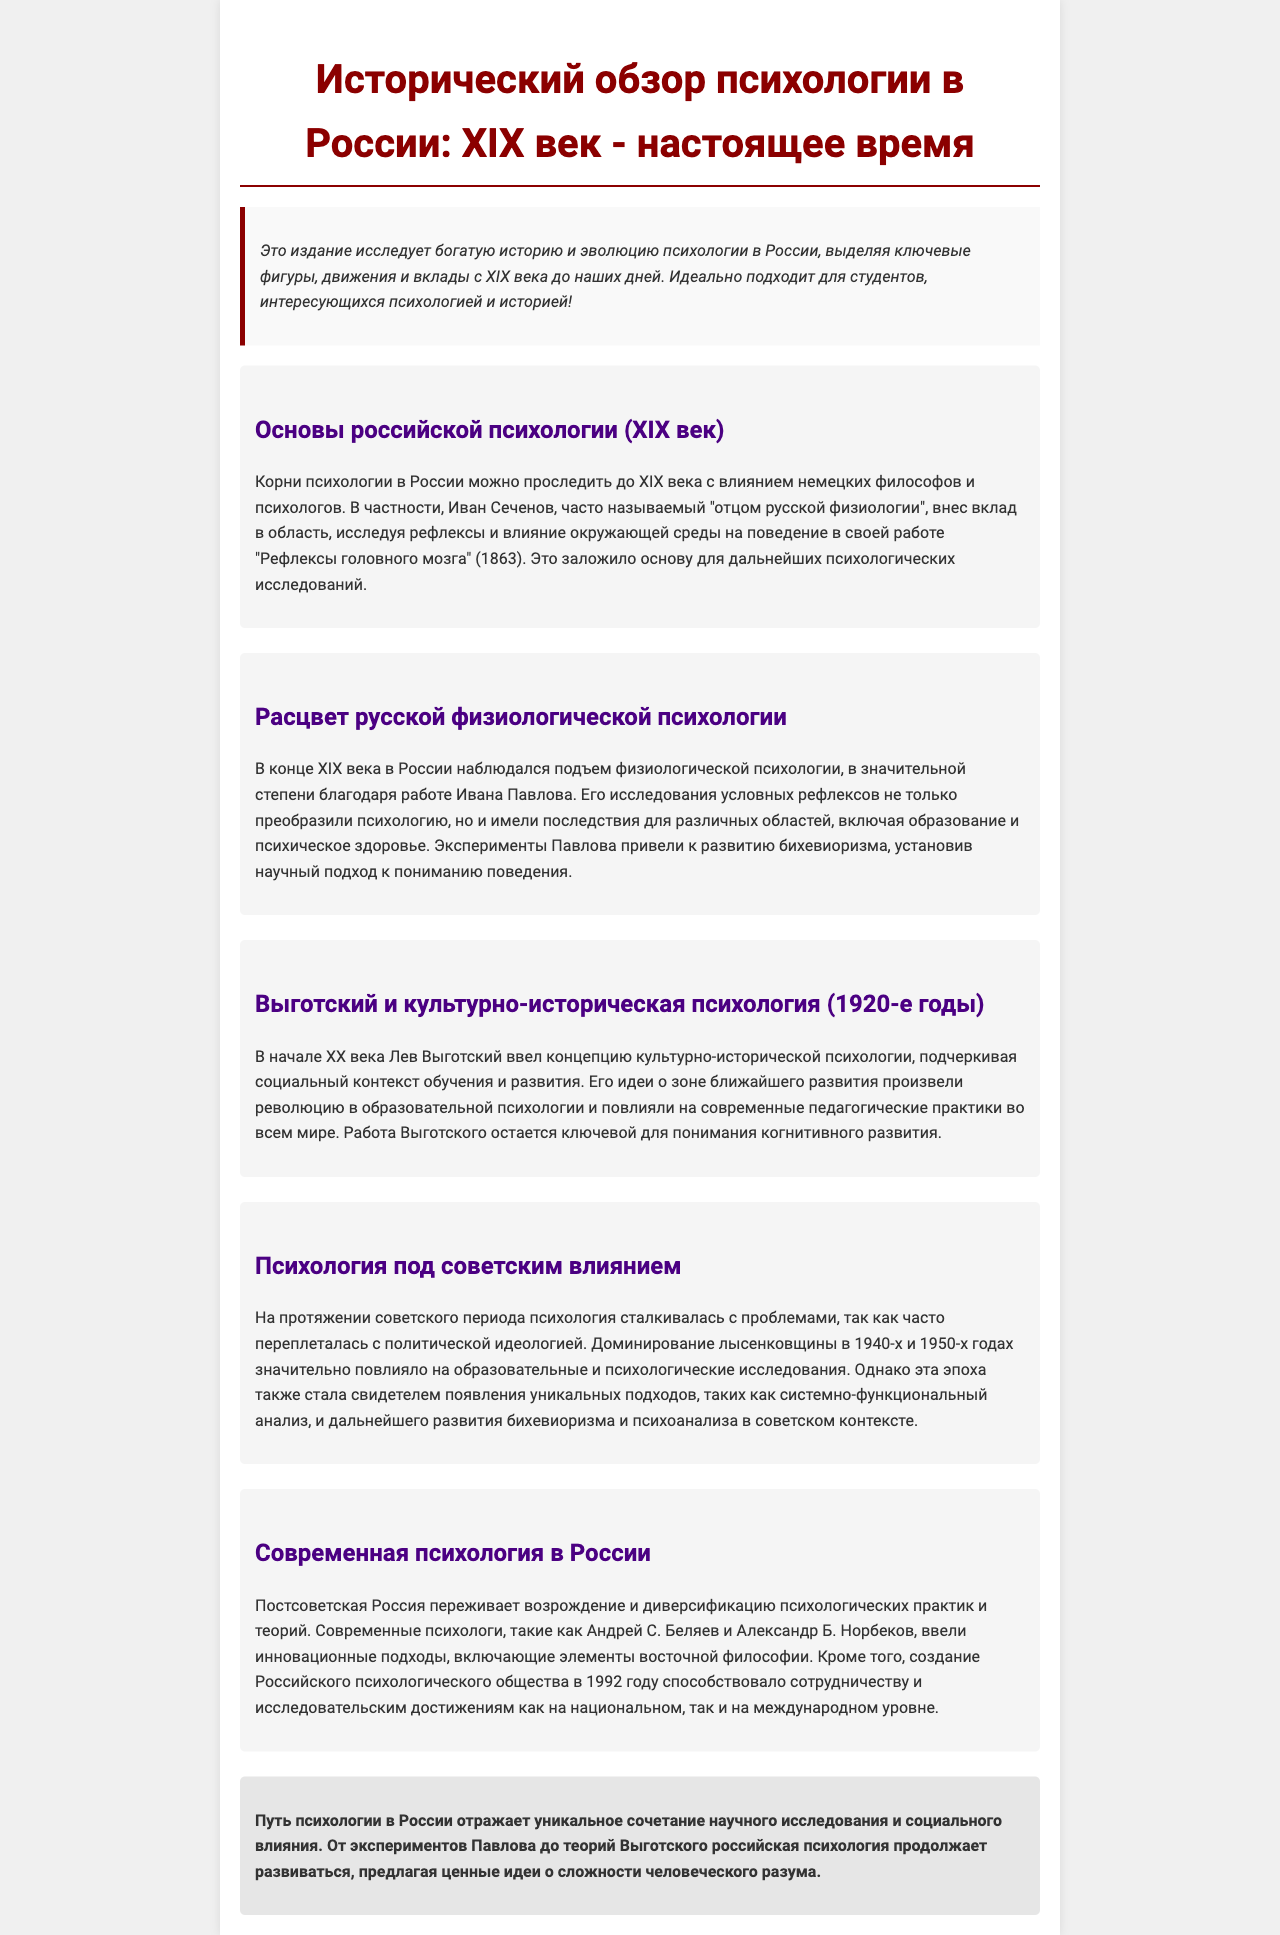what is the title of the document? The title is provided at the beginning of the document and summarizes its content as a historical overview.
Answer: Исторический обзор психологии в России: XIX век - настоящее время who is considered the father of Russian physiology? This information is given in the section about the foundations of Russian psychology.
Answer: Иван Сеченов what key concept did Lev Vygotsky introduce? The document outlines Vygotsky's contribution to psychology in relation to the social context of learning.
Answer: культурно-историческая психология in which decade did Vygotsky's work prominently influence educational psychology? The document specifies the time frame of Vygotsky's influential work.
Answer: 1920-е годы what significant psychological theory emerged from Ivan Pavlov's research? The text explains the impact of Pavlov’s experiments on the field of psychology.
Answer: бихевиоризм what year was the Russian Psychological Society founded? The document mentions the establishment of an important psychological organization in post-Soviet Russia.
Answer: 1992 how did Soviet ideology impact psychology? The relevant section discusses the relationship between political ideologies and psychological research during this period.
Answer: политической идеологией what does the conclusion emphasize about the development of psychology in Russia? The conclusion summarizes the overarching theme of the document regarding the evolution of psychology.
Answer: уникальное сочетание научного исследования и социального влияния 